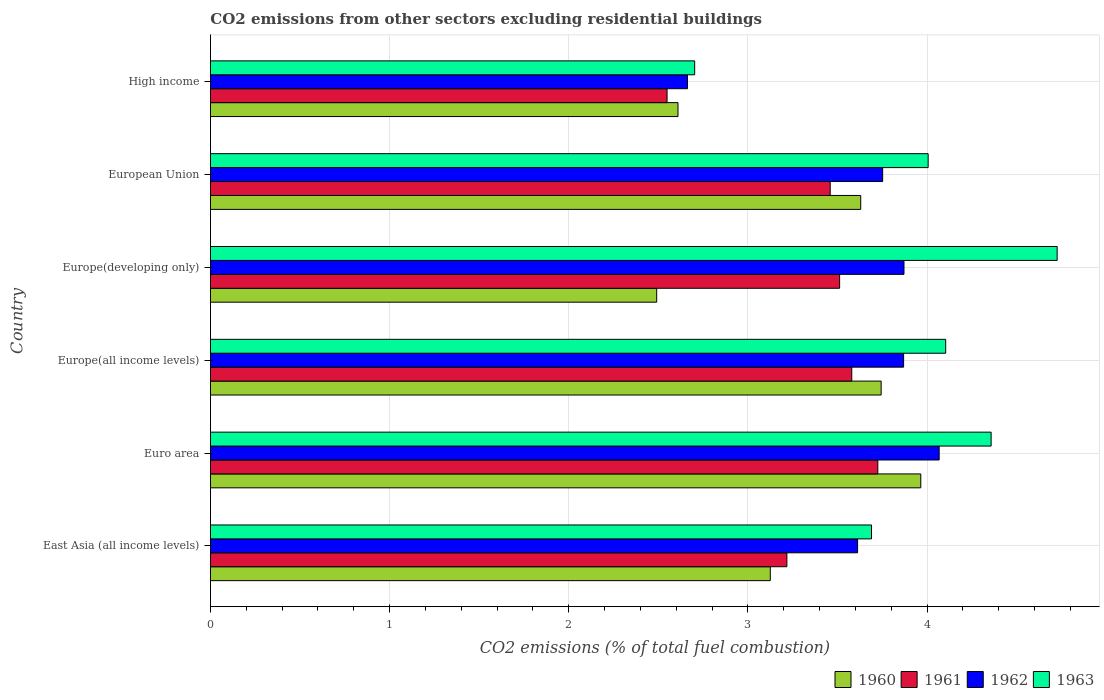Are the number of bars on each tick of the Y-axis equal?
Offer a very short reply. Yes. How many bars are there on the 3rd tick from the top?
Make the answer very short. 4. What is the label of the 4th group of bars from the top?
Offer a terse response. Europe(all income levels). In how many cases, is the number of bars for a given country not equal to the number of legend labels?
Provide a succinct answer. 0. What is the total CO2 emitted in 1963 in High income?
Make the answer very short. 2.7. Across all countries, what is the maximum total CO2 emitted in 1961?
Give a very brief answer. 3.73. Across all countries, what is the minimum total CO2 emitted in 1963?
Your response must be concise. 2.7. In which country was the total CO2 emitted in 1961 minimum?
Make the answer very short. High income. What is the total total CO2 emitted in 1962 in the graph?
Provide a short and direct response. 21.84. What is the difference between the total CO2 emitted in 1961 in East Asia (all income levels) and that in European Union?
Provide a short and direct response. -0.24. What is the difference between the total CO2 emitted in 1961 in High income and the total CO2 emitted in 1963 in East Asia (all income levels)?
Ensure brevity in your answer.  -1.14. What is the average total CO2 emitted in 1963 per country?
Your response must be concise. 3.93. What is the difference between the total CO2 emitted in 1960 and total CO2 emitted in 1963 in High income?
Your answer should be compact. -0.09. What is the ratio of the total CO2 emitted in 1962 in Europe(all income levels) to that in Europe(developing only)?
Ensure brevity in your answer.  1. Is the total CO2 emitted in 1962 in Europe(all income levels) less than that in High income?
Your answer should be compact. No. What is the difference between the highest and the second highest total CO2 emitted in 1961?
Offer a very short reply. 0.15. What is the difference between the highest and the lowest total CO2 emitted in 1963?
Keep it short and to the point. 2.02. Is it the case that in every country, the sum of the total CO2 emitted in 1960 and total CO2 emitted in 1962 is greater than the sum of total CO2 emitted in 1963 and total CO2 emitted in 1961?
Provide a succinct answer. No. What does the 1st bar from the bottom in High income represents?
Your answer should be very brief. 1960. Is it the case that in every country, the sum of the total CO2 emitted in 1961 and total CO2 emitted in 1960 is greater than the total CO2 emitted in 1963?
Give a very brief answer. Yes. How many bars are there?
Provide a succinct answer. 24. How many countries are there in the graph?
Keep it short and to the point. 6. What is the difference between two consecutive major ticks on the X-axis?
Provide a short and direct response. 1. How are the legend labels stacked?
Provide a succinct answer. Horizontal. What is the title of the graph?
Your answer should be very brief. CO2 emissions from other sectors excluding residential buildings. What is the label or title of the X-axis?
Your answer should be compact. CO2 emissions (% of total fuel combustion). What is the label or title of the Y-axis?
Offer a very short reply. Country. What is the CO2 emissions (% of total fuel combustion) of 1960 in East Asia (all income levels)?
Your answer should be compact. 3.13. What is the CO2 emissions (% of total fuel combustion) of 1961 in East Asia (all income levels)?
Offer a terse response. 3.22. What is the CO2 emissions (% of total fuel combustion) of 1962 in East Asia (all income levels)?
Provide a short and direct response. 3.61. What is the CO2 emissions (% of total fuel combustion) of 1963 in East Asia (all income levels)?
Your answer should be very brief. 3.69. What is the CO2 emissions (% of total fuel combustion) in 1960 in Euro area?
Your answer should be very brief. 3.97. What is the CO2 emissions (% of total fuel combustion) in 1961 in Euro area?
Your response must be concise. 3.73. What is the CO2 emissions (% of total fuel combustion) in 1962 in Euro area?
Provide a short and direct response. 4.07. What is the CO2 emissions (% of total fuel combustion) of 1963 in Euro area?
Make the answer very short. 4.36. What is the CO2 emissions (% of total fuel combustion) of 1960 in Europe(all income levels)?
Ensure brevity in your answer.  3.74. What is the CO2 emissions (% of total fuel combustion) in 1961 in Europe(all income levels)?
Your answer should be compact. 3.58. What is the CO2 emissions (% of total fuel combustion) in 1962 in Europe(all income levels)?
Give a very brief answer. 3.87. What is the CO2 emissions (% of total fuel combustion) in 1963 in Europe(all income levels)?
Your answer should be compact. 4.1. What is the CO2 emissions (% of total fuel combustion) in 1960 in Europe(developing only)?
Make the answer very short. 2.49. What is the CO2 emissions (% of total fuel combustion) in 1961 in Europe(developing only)?
Give a very brief answer. 3.51. What is the CO2 emissions (% of total fuel combustion) in 1962 in Europe(developing only)?
Give a very brief answer. 3.87. What is the CO2 emissions (% of total fuel combustion) in 1963 in Europe(developing only)?
Your response must be concise. 4.73. What is the CO2 emissions (% of total fuel combustion) of 1960 in European Union?
Offer a very short reply. 3.63. What is the CO2 emissions (% of total fuel combustion) of 1961 in European Union?
Offer a very short reply. 3.46. What is the CO2 emissions (% of total fuel combustion) in 1962 in European Union?
Offer a terse response. 3.75. What is the CO2 emissions (% of total fuel combustion) of 1963 in European Union?
Your response must be concise. 4.01. What is the CO2 emissions (% of total fuel combustion) of 1960 in High income?
Your response must be concise. 2.61. What is the CO2 emissions (% of total fuel combustion) of 1961 in High income?
Provide a succinct answer. 2.55. What is the CO2 emissions (% of total fuel combustion) of 1962 in High income?
Make the answer very short. 2.66. What is the CO2 emissions (% of total fuel combustion) of 1963 in High income?
Offer a very short reply. 2.7. Across all countries, what is the maximum CO2 emissions (% of total fuel combustion) in 1960?
Offer a terse response. 3.97. Across all countries, what is the maximum CO2 emissions (% of total fuel combustion) of 1961?
Your answer should be very brief. 3.73. Across all countries, what is the maximum CO2 emissions (% of total fuel combustion) in 1962?
Ensure brevity in your answer.  4.07. Across all countries, what is the maximum CO2 emissions (% of total fuel combustion) of 1963?
Offer a very short reply. 4.73. Across all countries, what is the minimum CO2 emissions (% of total fuel combustion) of 1960?
Ensure brevity in your answer.  2.49. Across all countries, what is the minimum CO2 emissions (% of total fuel combustion) in 1961?
Offer a very short reply. 2.55. Across all countries, what is the minimum CO2 emissions (% of total fuel combustion) of 1962?
Offer a very short reply. 2.66. Across all countries, what is the minimum CO2 emissions (% of total fuel combustion) of 1963?
Your answer should be very brief. 2.7. What is the total CO2 emissions (% of total fuel combustion) of 1960 in the graph?
Make the answer very short. 19.56. What is the total CO2 emissions (% of total fuel combustion) in 1961 in the graph?
Offer a very short reply. 20.04. What is the total CO2 emissions (% of total fuel combustion) in 1962 in the graph?
Ensure brevity in your answer.  21.84. What is the total CO2 emissions (% of total fuel combustion) of 1963 in the graph?
Your answer should be compact. 23.59. What is the difference between the CO2 emissions (% of total fuel combustion) of 1960 in East Asia (all income levels) and that in Euro area?
Provide a short and direct response. -0.84. What is the difference between the CO2 emissions (% of total fuel combustion) in 1961 in East Asia (all income levels) and that in Euro area?
Your answer should be very brief. -0.51. What is the difference between the CO2 emissions (% of total fuel combustion) of 1962 in East Asia (all income levels) and that in Euro area?
Make the answer very short. -0.46. What is the difference between the CO2 emissions (% of total fuel combustion) of 1963 in East Asia (all income levels) and that in Euro area?
Give a very brief answer. -0.67. What is the difference between the CO2 emissions (% of total fuel combustion) in 1960 in East Asia (all income levels) and that in Europe(all income levels)?
Offer a terse response. -0.62. What is the difference between the CO2 emissions (% of total fuel combustion) in 1961 in East Asia (all income levels) and that in Europe(all income levels)?
Offer a terse response. -0.36. What is the difference between the CO2 emissions (% of total fuel combustion) of 1962 in East Asia (all income levels) and that in Europe(all income levels)?
Ensure brevity in your answer.  -0.26. What is the difference between the CO2 emissions (% of total fuel combustion) in 1963 in East Asia (all income levels) and that in Europe(all income levels)?
Keep it short and to the point. -0.41. What is the difference between the CO2 emissions (% of total fuel combustion) of 1960 in East Asia (all income levels) and that in Europe(developing only)?
Your response must be concise. 0.63. What is the difference between the CO2 emissions (% of total fuel combustion) of 1961 in East Asia (all income levels) and that in Europe(developing only)?
Provide a short and direct response. -0.29. What is the difference between the CO2 emissions (% of total fuel combustion) in 1962 in East Asia (all income levels) and that in Europe(developing only)?
Your answer should be very brief. -0.26. What is the difference between the CO2 emissions (% of total fuel combustion) in 1963 in East Asia (all income levels) and that in Europe(developing only)?
Keep it short and to the point. -1.04. What is the difference between the CO2 emissions (% of total fuel combustion) of 1960 in East Asia (all income levels) and that in European Union?
Your response must be concise. -0.5. What is the difference between the CO2 emissions (% of total fuel combustion) in 1961 in East Asia (all income levels) and that in European Union?
Offer a terse response. -0.24. What is the difference between the CO2 emissions (% of total fuel combustion) of 1962 in East Asia (all income levels) and that in European Union?
Provide a short and direct response. -0.14. What is the difference between the CO2 emissions (% of total fuel combustion) in 1963 in East Asia (all income levels) and that in European Union?
Ensure brevity in your answer.  -0.32. What is the difference between the CO2 emissions (% of total fuel combustion) of 1960 in East Asia (all income levels) and that in High income?
Offer a terse response. 0.52. What is the difference between the CO2 emissions (% of total fuel combustion) in 1961 in East Asia (all income levels) and that in High income?
Your answer should be compact. 0.67. What is the difference between the CO2 emissions (% of total fuel combustion) in 1962 in East Asia (all income levels) and that in High income?
Provide a short and direct response. 0.95. What is the difference between the CO2 emissions (% of total fuel combustion) of 1960 in Euro area and that in Europe(all income levels)?
Your answer should be compact. 0.22. What is the difference between the CO2 emissions (% of total fuel combustion) of 1961 in Euro area and that in Europe(all income levels)?
Your answer should be very brief. 0.15. What is the difference between the CO2 emissions (% of total fuel combustion) in 1962 in Euro area and that in Europe(all income levels)?
Provide a short and direct response. 0.2. What is the difference between the CO2 emissions (% of total fuel combustion) in 1963 in Euro area and that in Europe(all income levels)?
Offer a terse response. 0.25. What is the difference between the CO2 emissions (% of total fuel combustion) in 1960 in Euro area and that in Europe(developing only)?
Offer a terse response. 1.47. What is the difference between the CO2 emissions (% of total fuel combustion) of 1961 in Euro area and that in Europe(developing only)?
Provide a short and direct response. 0.21. What is the difference between the CO2 emissions (% of total fuel combustion) in 1962 in Euro area and that in Europe(developing only)?
Make the answer very short. 0.2. What is the difference between the CO2 emissions (% of total fuel combustion) of 1963 in Euro area and that in Europe(developing only)?
Your answer should be very brief. -0.37. What is the difference between the CO2 emissions (% of total fuel combustion) of 1960 in Euro area and that in European Union?
Your answer should be very brief. 0.34. What is the difference between the CO2 emissions (% of total fuel combustion) in 1961 in Euro area and that in European Union?
Your response must be concise. 0.27. What is the difference between the CO2 emissions (% of total fuel combustion) in 1962 in Euro area and that in European Union?
Offer a terse response. 0.32. What is the difference between the CO2 emissions (% of total fuel combustion) in 1963 in Euro area and that in European Union?
Provide a succinct answer. 0.35. What is the difference between the CO2 emissions (% of total fuel combustion) of 1960 in Euro area and that in High income?
Your answer should be very brief. 1.36. What is the difference between the CO2 emissions (% of total fuel combustion) of 1961 in Euro area and that in High income?
Offer a terse response. 1.18. What is the difference between the CO2 emissions (% of total fuel combustion) in 1962 in Euro area and that in High income?
Provide a succinct answer. 1.41. What is the difference between the CO2 emissions (% of total fuel combustion) in 1963 in Euro area and that in High income?
Keep it short and to the point. 1.65. What is the difference between the CO2 emissions (% of total fuel combustion) of 1960 in Europe(all income levels) and that in Europe(developing only)?
Provide a succinct answer. 1.25. What is the difference between the CO2 emissions (% of total fuel combustion) in 1961 in Europe(all income levels) and that in Europe(developing only)?
Provide a succinct answer. 0.07. What is the difference between the CO2 emissions (% of total fuel combustion) in 1962 in Europe(all income levels) and that in Europe(developing only)?
Make the answer very short. -0. What is the difference between the CO2 emissions (% of total fuel combustion) in 1963 in Europe(all income levels) and that in Europe(developing only)?
Your answer should be very brief. -0.62. What is the difference between the CO2 emissions (% of total fuel combustion) of 1960 in Europe(all income levels) and that in European Union?
Offer a terse response. 0.11. What is the difference between the CO2 emissions (% of total fuel combustion) in 1961 in Europe(all income levels) and that in European Union?
Offer a very short reply. 0.12. What is the difference between the CO2 emissions (% of total fuel combustion) in 1962 in Europe(all income levels) and that in European Union?
Your answer should be very brief. 0.12. What is the difference between the CO2 emissions (% of total fuel combustion) of 1963 in Europe(all income levels) and that in European Union?
Offer a terse response. 0.1. What is the difference between the CO2 emissions (% of total fuel combustion) in 1960 in Europe(all income levels) and that in High income?
Keep it short and to the point. 1.13. What is the difference between the CO2 emissions (% of total fuel combustion) in 1961 in Europe(all income levels) and that in High income?
Your response must be concise. 1.03. What is the difference between the CO2 emissions (% of total fuel combustion) in 1962 in Europe(all income levels) and that in High income?
Provide a succinct answer. 1.21. What is the difference between the CO2 emissions (% of total fuel combustion) of 1963 in Europe(all income levels) and that in High income?
Make the answer very short. 1.4. What is the difference between the CO2 emissions (% of total fuel combustion) of 1960 in Europe(developing only) and that in European Union?
Provide a succinct answer. -1.14. What is the difference between the CO2 emissions (% of total fuel combustion) of 1961 in Europe(developing only) and that in European Union?
Provide a succinct answer. 0.05. What is the difference between the CO2 emissions (% of total fuel combustion) of 1962 in Europe(developing only) and that in European Union?
Provide a short and direct response. 0.12. What is the difference between the CO2 emissions (% of total fuel combustion) in 1963 in Europe(developing only) and that in European Union?
Your answer should be very brief. 0.72. What is the difference between the CO2 emissions (% of total fuel combustion) of 1960 in Europe(developing only) and that in High income?
Give a very brief answer. -0.12. What is the difference between the CO2 emissions (% of total fuel combustion) in 1961 in Europe(developing only) and that in High income?
Make the answer very short. 0.96. What is the difference between the CO2 emissions (% of total fuel combustion) in 1962 in Europe(developing only) and that in High income?
Your answer should be compact. 1.21. What is the difference between the CO2 emissions (% of total fuel combustion) in 1963 in Europe(developing only) and that in High income?
Your answer should be very brief. 2.02. What is the difference between the CO2 emissions (% of total fuel combustion) in 1960 in European Union and that in High income?
Ensure brevity in your answer.  1.02. What is the difference between the CO2 emissions (% of total fuel combustion) of 1961 in European Union and that in High income?
Provide a succinct answer. 0.91. What is the difference between the CO2 emissions (% of total fuel combustion) of 1962 in European Union and that in High income?
Your response must be concise. 1.09. What is the difference between the CO2 emissions (% of total fuel combustion) in 1963 in European Union and that in High income?
Your response must be concise. 1.3. What is the difference between the CO2 emissions (% of total fuel combustion) in 1960 in East Asia (all income levels) and the CO2 emissions (% of total fuel combustion) in 1961 in Euro area?
Keep it short and to the point. -0.6. What is the difference between the CO2 emissions (% of total fuel combustion) in 1960 in East Asia (all income levels) and the CO2 emissions (% of total fuel combustion) in 1962 in Euro area?
Your answer should be very brief. -0.94. What is the difference between the CO2 emissions (% of total fuel combustion) in 1960 in East Asia (all income levels) and the CO2 emissions (% of total fuel combustion) in 1963 in Euro area?
Provide a short and direct response. -1.23. What is the difference between the CO2 emissions (% of total fuel combustion) in 1961 in East Asia (all income levels) and the CO2 emissions (% of total fuel combustion) in 1962 in Euro area?
Ensure brevity in your answer.  -0.85. What is the difference between the CO2 emissions (% of total fuel combustion) in 1961 in East Asia (all income levels) and the CO2 emissions (% of total fuel combustion) in 1963 in Euro area?
Make the answer very short. -1.14. What is the difference between the CO2 emissions (% of total fuel combustion) in 1962 in East Asia (all income levels) and the CO2 emissions (% of total fuel combustion) in 1963 in Euro area?
Your response must be concise. -0.75. What is the difference between the CO2 emissions (% of total fuel combustion) of 1960 in East Asia (all income levels) and the CO2 emissions (% of total fuel combustion) of 1961 in Europe(all income levels)?
Keep it short and to the point. -0.45. What is the difference between the CO2 emissions (% of total fuel combustion) of 1960 in East Asia (all income levels) and the CO2 emissions (% of total fuel combustion) of 1962 in Europe(all income levels)?
Offer a very short reply. -0.74. What is the difference between the CO2 emissions (% of total fuel combustion) of 1960 in East Asia (all income levels) and the CO2 emissions (% of total fuel combustion) of 1963 in Europe(all income levels)?
Keep it short and to the point. -0.98. What is the difference between the CO2 emissions (% of total fuel combustion) of 1961 in East Asia (all income levels) and the CO2 emissions (% of total fuel combustion) of 1962 in Europe(all income levels)?
Ensure brevity in your answer.  -0.65. What is the difference between the CO2 emissions (% of total fuel combustion) in 1961 in East Asia (all income levels) and the CO2 emissions (% of total fuel combustion) in 1963 in Europe(all income levels)?
Provide a succinct answer. -0.89. What is the difference between the CO2 emissions (% of total fuel combustion) in 1962 in East Asia (all income levels) and the CO2 emissions (% of total fuel combustion) in 1963 in Europe(all income levels)?
Keep it short and to the point. -0.49. What is the difference between the CO2 emissions (% of total fuel combustion) of 1960 in East Asia (all income levels) and the CO2 emissions (% of total fuel combustion) of 1961 in Europe(developing only)?
Offer a very short reply. -0.39. What is the difference between the CO2 emissions (% of total fuel combustion) in 1960 in East Asia (all income levels) and the CO2 emissions (% of total fuel combustion) in 1962 in Europe(developing only)?
Make the answer very short. -0.75. What is the difference between the CO2 emissions (% of total fuel combustion) in 1960 in East Asia (all income levels) and the CO2 emissions (% of total fuel combustion) in 1963 in Europe(developing only)?
Keep it short and to the point. -1.6. What is the difference between the CO2 emissions (% of total fuel combustion) in 1961 in East Asia (all income levels) and the CO2 emissions (% of total fuel combustion) in 1962 in Europe(developing only)?
Offer a terse response. -0.65. What is the difference between the CO2 emissions (% of total fuel combustion) of 1961 in East Asia (all income levels) and the CO2 emissions (% of total fuel combustion) of 1963 in Europe(developing only)?
Your answer should be compact. -1.51. What is the difference between the CO2 emissions (% of total fuel combustion) in 1962 in East Asia (all income levels) and the CO2 emissions (% of total fuel combustion) in 1963 in Europe(developing only)?
Make the answer very short. -1.11. What is the difference between the CO2 emissions (% of total fuel combustion) of 1960 in East Asia (all income levels) and the CO2 emissions (% of total fuel combustion) of 1961 in European Union?
Make the answer very short. -0.33. What is the difference between the CO2 emissions (% of total fuel combustion) of 1960 in East Asia (all income levels) and the CO2 emissions (% of total fuel combustion) of 1962 in European Union?
Offer a terse response. -0.63. What is the difference between the CO2 emissions (% of total fuel combustion) in 1960 in East Asia (all income levels) and the CO2 emissions (% of total fuel combustion) in 1963 in European Union?
Your answer should be very brief. -0.88. What is the difference between the CO2 emissions (% of total fuel combustion) of 1961 in East Asia (all income levels) and the CO2 emissions (% of total fuel combustion) of 1962 in European Union?
Keep it short and to the point. -0.53. What is the difference between the CO2 emissions (% of total fuel combustion) of 1961 in East Asia (all income levels) and the CO2 emissions (% of total fuel combustion) of 1963 in European Union?
Provide a short and direct response. -0.79. What is the difference between the CO2 emissions (% of total fuel combustion) in 1962 in East Asia (all income levels) and the CO2 emissions (% of total fuel combustion) in 1963 in European Union?
Provide a succinct answer. -0.39. What is the difference between the CO2 emissions (% of total fuel combustion) of 1960 in East Asia (all income levels) and the CO2 emissions (% of total fuel combustion) of 1961 in High income?
Give a very brief answer. 0.58. What is the difference between the CO2 emissions (% of total fuel combustion) of 1960 in East Asia (all income levels) and the CO2 emissions (% of total fuel combustion) of 1962 in High income?
Provide a succinct answer. 0.46. What is the difference between the CO2 emissions (% of total fuel combustion) of 1960 in East Asia (all income levels) and the CO2 emissions (% of total fuel combustion) of 1963 in High income?
Give a very brief answer. 0.42. What is the difference between the CO2 emissions (% of total fuel combustion) in 1961 in East Asia (all income levels) and the CO2 emissions (% of total fuel combustion) in 1962 in High income?
Give a very brief answer. 0.55. What is the difference between the CO2 emissions (% of total fuel combustion) of 1961 in East Asia (all income levels) and the CO2 emissions (% of total fuel combustion) of 1963 in High income?
Ensure brevity in your answer.  0.51. What is the difference between the CO2 emissions (% of total fuel combustion) of 1962 in East Asia (all income levels) and the CO2 emissions (% of total fuel combustion) of 1963 in High income?
Provide a succinct answer. 0.91. What is the difference between the CO2 emissions (% of total fuel combustion) in 1960 in Euro area and the CO2 emissions (% of total fuel combustion) in 1961 in Europe(all income levels)?
Your answer should be compact. 0.39. What is the difference between the CO2 emissions (% of total fuel combustion) in 1960 in Euro area and the CO2 emissions (% of total fuel combustion) in 1962 in Europe(all income levels)?
Your answer should be very brief. 0.1. What is the difference between the CO2 emissions (% of total fuel combustion) in 1960 in Euro area and the CO2 emissions (% of total fuel combustion) in 1963 in Europe(all income levels)?
Offer a very short reply. -0.14. What is the difference between the CO2 emissions (% of total fuel combustion) in 1961 in Euro area and the CO2 emissions (% of total fuel combustion) in 1962 in Europe(all income levels)?
Your answer should be very brief. -0.14. What is the difference between the CO2 emissions (% of total fuel combustion) in 1961 in Euro area and the CO2 emissions (% of total fuel combustion) in 1963 in Europe(all income levels)?
Your response must be concise. -0.38. What is the difference between the CO2 emissions (% of total fuel combustion) in 1962 in Euro area and the CO2 emissions (% of total fuel combustion) in 1963 in Europe(all income levels)?
Your answer should be very brief. -0.04. What is the difference between the CO2 emissions (% of total fuel combustion) of 1960 in Euro area and the CO2 emissions (% of total fuel combustion) of 1961 in Europe(developing only)?
Give a very brief answer. 0.45. What is the difference between the CO2 emissions (% of total fuel combustion) of 1960 in Euro area and the CO2 emissions (% of total fuel combustion) of 1962 in Europe(developing only)?
Provide a short and direct response. 0.09. What is the difference between the CO2 emissions (% of total fuel combustion) in 1960 in Euro area and the CO2 emissions (% of total fuel combustion) in 1963 in Europe(developing only)?
Offer a very short reply. -0.76. What is the difference between the CO2 emissions (% of total fuel combustion) of 1961 in Euro area and the CO2 emissions (% of total fuel combustion) of 1962 in Europe(developing only)?
Provide a short and direct response. -0.15. What is the difference between the CO2 emissions (% of total fuel combustion) of 1961 in Euro area and the CO2 emissions (% of total fuel combustion) of 1963 in Europe(developing only)?
Your answer should be compact. -1. What is the difference between the CO2 emissions (% of total fuel combustion) of 1962 in Euro area and the CO2 emissions (% of total fuel combustion) of 1963 in Europe(developing only)?
Your answer should be very brief. -0.66. What is the difference between the CO2 emissions (% of total fuel combustion) in 1960 in Euro area and the CO2 emissions (% of total fuel combustion) in 1961 in European Union?
Keep it short and to the point. 0.51. What is the difference between the CO2 emissions (% of total fuel combustion) in 1960 in Euro area and the CO2 emissions (% of total fuel combustion) in 1962 in European Union?
Your response must be concise. 0.21. What is the difference between the CO2 emissions (% of total fuel combustion) of 1960 in Euro area and the CO2 emissions (% of total fuel combustion) of 1963 in European Union?
Make the answer very short. -0.04. What is the difference between the CO2 emissions (% of total fuel combustion) of 1961 in Euro area and the CO2 emissions (% of total fuel combustion) of 1962 in European Union?
Offer a very short reply. -0.03. What is the difference between the CO2 emissions (% of total fuel combustion) in 1961 in Euro area and the CO2 emissions (% of total fuel combustion) in 1963 in European Union?
Keep it short and to the point. -0.28. What is the difference between the CO2 emissions (% of total fuel combustion) of 1962 in Euro area and the CO2 emissions (% of total fuel combustion) of 1963 in European Union?
Offer a terse response. 0.06. What is the difference between the CO2 emissions (% of total fuel combustion) of 1960 in Euro area and the CO2 emissions (% of total fuel combustion) of 1961 in High income?
Your response must be concise. 1.42. What is the difference between the CO2 emissions (% of total fuel combustion) in 1960 in Euro area and the CO2 emissions (% of total fuel combustion) in 1962 in High income?
Provide a short and direct response. 1.3. What is the difference between the CO2 emissions (% of total fuel combustion) in 1960 in Euro area and the CO2 emissions (% of total fuel combustion) in 1963 in High income?
Make the answer very short. 1.26. What is the difference between the CO2 emissions (% of total fuel combustion) in 1961 in Euro area and the CO2 emissions (% of total fuel combustion) in 1963 in High income?
Your answer should be compact. 1.02. What is the difference between the CO2 emissions (% of total fuel combustion) of 1962 in Euro area and the CO2 emissions (% of total fuel combustion) of 1963 in High income?
Offer a very short reply. 1.36. What is the difference between the CO2 emissions (% of total fuel combustion) in 1960 in Europe(all income levels) and the CO2 emissions (% of total fuel combustion) in 1961 in Europe(developing only)?
Provide a succinct answer. 0.23. What is the difference between the CO2 emissions (% of total fuel combustion) of 1960 in Europe(all income levels) and the CO2 emissions (% of total fuel combustion) of 1962 in Europe(developing only)?
Keep it short and to the point. -0.13. What is the difference between the CO2 emissions (% of total fuel combustion) in 1960 in Europe(all income levels) and the CO2 emissions (% of total fuel combustion) in 1963 in Europe(developing only)?
Provide a short and direct response. -0.98. What is the difference between the CO2 emissions (% of total fuel combustion) of 1961 in Europe(all income levels) and the CO2 emissions (% of total fuel combustion) of 1962 in Europe(developing only)?
Offer a very short reply. -0.29. What is the difference between the CO2 emissions (% of total fuel combustion) of 1961 in Europe(all income levels) and the CO2 emissions (% of total fuel combustion) of 1963 in Europe(developing only)?
Make the answer very short. -1.15. What is the difference between the CO2 emissions (% of total fuel combustion) in 1962 in Europe(all income levels) and the CO2 emissions (% of total fuel combustion) in 1963 in Europe(developing only)?
Provide a short and direct response. -0.86. What is the difference between the CO2 emissions (% of total fuel combustion) of 1960 in Europe(all income levels) and the CO2 emissions (% of total fuel combustion) of 1961 in European Union?
Your answer should be compact. 0.28. What is the difference between the CO2 emissions (% of total fuel combustion) in 1960 in Europe(all income levels) and the CO2 emissions (% of total fuel combustion) in 1962 in European Union?
Give a very brief answer. -0.01. What is the difference between the CO2 emissions (% of total fuel combustion) in 1960 in Europe(all income levels) and the CO2 emissions (% of total fuel combustion) in 1963 in European Union?
Offer a very short reply. -0.26. What is the difference between the CO2 emissions (% of total fuel combustion) in 1961 in Europe(all income levels) and the CO2 emissions (% of total fuel combustion) in 1962 in European Union?
Make the answer very short. -0.17. What is the difference between the CO2 emissions (% of total fuel combustion) of 1961 in Europe(all income levels) and the CO2 emissions (% of total fuel combustion) of 1963 in European Union?
Your answer should be compact. -0.43. What is the difference between the CO2 emissions (% of total fuel combustion) of 1962 in Europe(all income levels) and the CO2 emissions (% of total fuel combustion) of 1963 in European Union?
Your response must be concise. -0.14. What is the difference between the CO2 emissions (% of total fuel combustion) of 1960 in Europe(all income levels) and the CO2 emissions (% of total fuel combustion) of 1961 in High income?
Provide a short and direct response. 1.2. What is the difference between the CO2 emissions (% of total fuel combustion) of 1960 in Europe(all income levels) and the CO2 emissions (% of total fuel combustion) of 1962 in High income?
Your answer should be compact. 1.08. What is the difference between the CO2 emissions (% of total fuel combustion) of 1960 in Europe(all income levels) and the CO2 emissions (% of total fuel combustion) of 1963 in High income?
Ensure brevity in your answer.  1.04. What is the difference between the CO2 emissions (% of total fuel combustion) of 1961 in Europe(all income levels) and the CO2 emissions (% of total fuel combustion) of 1962 in High income?
Offer a very short reply. 0.92. What is the difference between the CO2 emissions (% of total fuel combustion) of 1961 in Europe(all income levels) and the CO2 emissions (% of total fuel combustion) of 1963 in High income?
Keep it short and to the point. 0.88. What is the difference between the CO2 emissions (% of total fuel combustion) of 1962 in Europe(all income levels) and the CO2 emissions (% of total fuel combustion) of 1963 in High income?
Keep it short and to the point. 1.17. What is the difference between the CO2 emissions (% of total fuel combustion) of 1960 in Europe(developing only) and the CO2 emissions (% of total fuel combustion) of 1961 in European Union?
Make the answer very short. -0.97. What is the difference between the CO2 emissions (% of total fuel combustion) in 1960 in Europe(developing only) and the CO2 emissions (% of total fuel combustion) in 1962 in European Union?
Your answer should be very brief. -1.26. What is the difference between the CO2 emissions (% of total fuel combustion) in 1960 in Europe(developing only) and the CO2 emissions (% of total fuel combustion) in 1963 in European Union?
Make the answer very short. -1.52. What is the difference between the CO2 emissions (% of total fuel combustion) in 1961 in Europe(developing only) and the CO2 emissions (% of total fuel combustion) in 1962 in European Union?
Keep it short and to the point. -0.24. What is the difference between the CO2 emissions (% of total fuel combustion) in 1961 in Europe(developing only) and the CO2 emissions (% of total fuel combustion) in 1963 in European Union?
Provide a succinct answer. -0.49. What is the difference between the CO2 emissions (% of total fuel combustion) of 1962 in Europe(developing only) and the CO2 emissions (% of total fuel combustion) of 1963 in European Union?
Your answer should be compact. -0.14. What is the difference between the CO2 emissions (% of total fuel combustion) in 1960 in Europe(developing only) and the CO2 emissions (% of total fuel combustion) in 1961 in High income?
Offer a very short reply. -0.06. What is the difference between the CO2 emissions (% of total fuel combustion) in 1960 in Europe(developing only) and the CO2 emissions (% of total fuel combustion) in 1962 in High income?
Offer a terse response. -0.17. What is the difference between the CO2 emissions (% of total fuel combustion) in 1960 in Europe(developing only) and the CO2 emissions (% of total fuel combustion) in 1963 in High income?
Offer a terse response. -0.21. What is the difference between the CO2 emissions (% of total fuel combustion) of 1961 in Europe(developing only) and the CO2 emissions (% of total fuel combustion) of 1962 in High income?
Offer a very short reply. 0.85. What is the difference between the CO2 emissions (% of total fuel combustion) in 1961 in Europe(developing only) and the CO2 emissions (% of total fuel combustion) in 1963 in High income?
Your answer should be very brief. 0.81. What is the difference between the CO2 emissions (% of total fuel combustion) of 1962 in Europe(developing only) and the CO2 emissions (% of total fuel combustion) of 1963 in High income?
Give a very brief answer. 1.17. What is the difference between the CO2 emissions (% of total fuel combustion) of 1960 in European Union and the CO2 emissions (% of total fuel combustion) of 1961 in High income?
Offer a terse response. 1.08. What is the difference between the CO2 emissions (% of total fuel combustion) in 1960 in European Union and the CO2 emissions (% of total fuel combustion) in 1962 in High income?
Offer a terse response. 0.97. What is the difference between the CO2 emissions (% of total fuel combustion) in 1960 in European Union and the CO2 emissions (% of total fuel combustion) in 1963 in High income?
Give a very brief answer. 0.93. What is the difference between the CO2 emissions (% of total fuel combustion) in 1961 in European Union and the CO2 emissions (% of total fuel combustion) in 1962 in High income?
Provide a short and direct response. 0.8. What is the difference between the CO2 emissions (% of total fuel combustion) in 1961 in European Union and the CO2 emissions (% of total fuel combustion) in 1963 in High income?
Your answer should be very brief. 0.76. What is the difference between the CO2 emissions (% of total fuel combustion) of 1962 in European Union and the CO2 emissions (% of total fuel combustion) of 1963 in High income?
Your response must be concise. 1.05. What is the average CO2 emissions (% of total fuel combustion) of 1960 per country?
Keep it short and to the point. 3.26. What is the average CO2 emissions (% of total fuel combustion) of 1961 per country?
Keep it short and to the point. 3.34. What is the average CO2 emissions (% of total fuel combustion) of 1962 per country?
Give a very brief answer. 3.64. What is the average CO2 emissions (% of total fuel combustion) of 1963 per country?
Make the answer very short. 3.93. What is the difference between the CO2 emissions (% of total fuel combustion) of 1960 and CO2 emissions (% of total fuel combustion) of 1961 in East Asia (all income levels)?
Provide a succinct answer. -0.09. What is the difference between the CO2 emissions (% of total fuel combustion) in 1960 and CO2 emissions (% of total fuel combustion) in 1962 in East Asia (all income levels)?
Provide a succinct answer. -0.49. What is the difference between the CO2 emissions (% of total fuel combustion) in 1960 and CO2 emissions (% of total fuel combustion) in 1963 in East Asia (all income levels)?
Your answer should be compact. -0.56. What is the difference between the CO2 emissions (% of total fuel combustion) in 1961 and CO2 emissions (% of total fuel combustion) in 1962 in East Asia (all income levels)?
Make the answer very short. -0.39. What is the difference between the CO2 emissions (% of total fuel combustion) in 1961 and CO2 emissions (% of total fuel combustion) in 1963 in East Asia (all income levels)?
Your response must be concise. -0.47. What is the difference between the CO2 emissions (% of total fuel combustion) in 1962 and CO2 emissions (% of total fuel combustion) in 1963 in East Asia (all income levels)?
Give a very brief answer. -0.08. What is the difference between the CO2 emissions (% of total fuel combustion) in 1960 and CO2 emissions (% of total fuel combustion) in 1961 in Euro area?
Offer a terse response. 0.24. What is the difference between the CO2 emissions (% of total fuel combustion) in 1960 and CO2 emissions (% of total fuel combustion) in 1962 in Euro area?
Provide a short and direct response. -0.1. What is the difference between the CO2 emissions (% of total fuel combustion) in 1960 and CO2 emissions (% of total fuel combustion) in 1963 in Euro area?
Offer a terse response. -0.39. What is the difference between the CO2 emissions (% of total fuel combustion) in 1961 and CO2 emissions (% of total fuel combustion) in 1962 in Euro area?
Provide a short and direct response. -0.34. What is the difference between the CO2 emissions (% of total fuel combustion) of 1961 and CO2 emissions (% of total fuel combustion) of 1963 in Euro area?
Offer a terse response. -0.63. What is the difference between the CO2 emissions (% of total fuel combustion) in 1962 and CO2 emissions (% of total fuel combustion) in 1963 in Euro area?
Offer a very short reply. -0.29. What is the difference between the CO2 emissions (% of total fuel combustion) of 1960 and CO2 emissions (% of total fuel combustion) of 1961 in Europe(all income levels)?
Make the answer very short. 0.16. What is the difference between the CO2 emissions (% of total fuel combustion) of 1960 and CO2 emissions (% of total fuel combustion) of 1962 in Europe(all income levels)?
Provide a succinct answer. -0.13. What is the difference between the CO2 emissions (% of total fuel combustion) in 1960 and CO2 emissions (% of total fuel combustion) in 1963 in Europe(all income levels)?
Provide a short and direct response. -0.36. What is the difference between the CO2 emissions (% of total fuel combustion) of 1961 and CO2 emissions (% of total fuel combustion) of 1962 in Europe(all income levels)?
Offer a very short reply. -0.29. What is the difference between the CO2 emissions (% of total fuel combustion) of 1961 and CO2 emissions (% of total fuel combustion) of 1963 in Europe(all income levels)?
Your response must be concise. -0.52. What is the difference between the CO2 emissions (% of total fuel combustion) in 1962 and CO2 emissions (% of total fuel combustion) in 1963 in Europe(all income levels)?
Your answer should be very brief. -0.23. What is the difference between the CO2 emissions (% of total fuel combustion) in 1960 and CO2 emissions (% of total fuel combustion) in 1961 in Europe(developing only)?
Your answer should be very brief. -1.02. What is the difference between the CO2 emissions (% of total fuel combustion) in 1960 and CO2 emissions (% of total fuel combustion) in 1962 in Europe(developing only)?
Your answer should be very brief. -1.38. What is the difference between the CO2 emissions (% of total fuel combustion) of 1960 and CO2 emissions (% of total fuel combustion) of 1963 in Europe(developing only)?
Your answer should be compact. -2.24. What is the difference between the CO2 emissions (% of total fuel combustion) of 1961 and CO2 emissions (% of total fuel combustion) of 1962 in Europe(developing only)?
Give a very brief answer. -0.36. What is the difference between the CO2 emissions (% of total fuel combustion) of 1961 and CO2 emissions (% of total fuel combustion) of 1963 in Europe(developing only)?
Your answer should be compact. -1.21. What is the difference between the CO2 emissions (% of total fuel combustion) in 1962 and CO2 emissions (% of total fuel combustion) in 1963 in Europe(developing only)?
Your response must be concise. -0.85. What is the difference between the CO2 emissions (% of total fuel combustion) in 1960 and CO2 emissions (% of total fuel combustion) in 1961 in European Union?
Offer a terse response. 0.17. What is the difference between the CO2 emissions (% of total fuel combustion) of 1960 and CO2 emissions (% of total fuel combustion) of 1962 in European Union?
Your answer should be very brief. -0.12. What is the difference between the CO2 emissions (% of total fuel combustion) of 1960 and CO2 emissions (% of total fuel combustion) of 1963 in European Union?
Give a very brief answer. -0.38. What is the difference between the CO2 emissions (% of total fuel combustion) of 1961 and CO2 emissions (% of total fuel combustion) of 1962 in European Union?
Give a very brief answer. -0.29. What is the difference between the CO2 emissions (% of total fuel combustion) of 1961 and CO2 emissions (% of total fuel combustion) of 1963 in European Union?
Provide a succinct answer. -0.55. What is the difference between the CO2 emissions (% of total fuel combustion) in 1962 and CO2 emissions (% of total fuel combustion) in 1963 in European Union?
Provide a succinct answer. -0.25. What is the difference between the CO2 emissions (% of total fuel combustion) in 1960 and CO2 emissions (% of total fuel combustion) in 1961 in High income?
Your response must be concise. 0.06. What is the difference between the CO2 emissions (% of total fuel combustion) of 1960 and CO2 emissions (% of total fuel combustion) of 1962 in High income?
Your answer should be compact. -0.05. What is the difference between the CO2 emissions (% of total fuel combustion) of 1960 and CO2 emissions (% of total fuel combustion) of 1963 in High income?
Ensure brevity in your answer.  -0.09. What is the difference between the CO2 emissions (% of total fuel combustion) of 1961 and CO2 emissions (% of total fuel combustion) of 1962 in High income?
Give a very brief answer. -0.11. What is the difference between the CO2 emissions (% of total fuel combustion) in 1961 and CO2 emissions (% of total fuel combustion) in 1963 in High income?
Provide a short and direct response. -0.15. What is the difference between the CO2 emissions (% of total fuel combustion) in 1962 and CO2 emissions (% of total fuel combustion) in 1963 in High income?
Your answer should be compact. -0.04. What is the ratio of the CO2 emissions (% of total fuel combustion) of 1960 in East Asia (all income levels) to that in Euro area?
Your answer should be very brief. 0.79. What is the ratio of the CO2 emissions (% of total fuel combustion) in 1961 in East Asia (all income levels) to that in Euro area?
Offer a very short reply. 0.86. What is the ratio of the CO2 emissions (% of total fuel combustion) of 1962 in East Asia (all income levels) to that in Euro area?
Give a very brief answer. 0.89. What is the ratio of the CO2 emissions (% of total fuel combustion) in 1963 in East Asia (all income levels) to that in Euro area?
Provide a short and direct response. 0.85. What is the ratio of the CO2 emissions (% of total fuel combustion) in 1960 in East Asia (all income levels) to that in Europe(all income levels)?
Your answer should be very brief. 0.83. What is the ratio of the CO2 emissions (% of total fuel combustion) in 1961 in East Asia (all income levels) to that in Europe(all income levels)?
Keep it short and to the point. 0.9. What is the ratio of the CO2 emissions (% of total fuel combustion) in 1962 in East Asia (all income levels) to that in Europe(all income levels)?
Provide a succinct answer. 0.93. What is the ratio of the CO2 emissions (% of total fuel combustion) of 1963 in East Asia (all income levels) to that in Europe(all income levels)?
Offer a very short reply. 0.9. What is the ratio of the CO2 emissions (% of total fuel combustion) of 1960 in East Asia (all income levels) to that in Europe(developing only)?
Offer a very short reply. 1.25. What is the ratio of the CO2 emissions (% of total fuel combustion) of 1961 in East Asia (all income levels) to that in Europe(developing only)?
Ensure brevity in your answer.  0.92. What is the ratio of the CO2 emissions (% of total fuel combustion) in 1962 in East Asia (all income levels) to that in Europe(developing only)?
Your answer should be very brief. 0.93. What is the ratio of the CO2 emissions (% of total fuel combustion) of 1963 in East Asia (all income levels) to that in Europe(developing only)?
Offer a very short reply. 0.78. What is the ratio of the CO2 emissions (% of total fuel combustion) of 1960 in East Asia (all income levels) to that in European Union?
Provide a succinct answer. 0.86. What is the ratio of the CO2 emissions (% of total fuel combustion) in 1961 in East Asia (all income levels) to that in European Union?
Offer a very short reply. 0.93. What is the ratio of the CO2 emissions (% of total fuel combustion) of 1962 in East Asia (all income levels) to that in European Union?
Provide a succinct answer. 0.96. What is the ratio of the CO2 emissions (% of total fuel combustion) of 1963 in East Asia (all income levels) to that in European Union?
Ensure brevity in your answer.  0.92. What is the ratio of the CO2 emissions (% of total fuel combustion) of 1960 in East Asia (all income levels) to that in High income?
Ensure brevity in your answer.  1.2. What is the ratio of the CO2 emissions (% of total fuel combustion) of 1961 in East Asia (all income levels) to that in High income?
Provide a short and direct response. 1.26. What is the ratio of the CO2 emissions (% of total fuel combustion) of 1962 in East Asia (all income levels) to that in High income?
Your response must be concise. 1.36. What is the ratio of the CO2 emissions (% of total fuel combustion) of 1963 in East Asia (all income levels) to that in High income?
Provide a short and direct response. 1.37. What is the ratio of the CO2 emissions (% of total fuel combustion) of 1960 in Euro area to that in Europe(all income levels)?
Your response must be concise. 1.06. What is the ratio of the CO2 emissions (% of total fuel combustion) of 1961 in Euro area to that in Europe(all income levels)?
Provide a succinct answer. 1.04. What is the ratio of the CO2 emissions (% of total fuel combustion) in 1962 in Euro area to that in Europe(all income levels)?
Offer a terse response. 1.05. What is the ratio of the CO2 emissions (% of total fuel combustion) of 1963 in Euro area to that in Europe(all income levels)?
Keep it short and to the point. 1.06. What is the ratio of the CO2 emissions (% of total fuel combustion) of 1960 in Euro area to that in Europe(developing only)?
Your answer should be compact. 1.59. What is the ratio of the CO2 emissions (% of total fuel combustion) of 1961 in Euro area to that in Europe(developing only)?
Your answer should be very brief. 1.06. What is the ratio of the CO2 emissions (% of total fuel combustion) of 1962 in Euro area to that in Europe(developing only)?
Give a very brief answer. 1.05. What is the ratio of the CO2 emissions (% of total fuel combustion) of 1963 in Euro area to that in Europe(developing only)?
Your answer should be very brief. 0.92. What is the ratio of the CO2 emissions (% of total fuel combustion) of 1960 in Euro area to that in European Union?
Offer a very short reply. 1.09. What is the ratio of the CO2 emissions (% of total fuel combustion) of 1961 in Euro area to that in European Union?
Give a very brief answer. 1.08. What is the ratio of the CO2 emissions (% of total fuel combustion) in 1962 in Euro area to that in European Union?
Give a very brief answer. 1.08. What is the ratio of the CO2 emissions (% of total fuel combustion) in 1963 in Euro area to that in European Union?
Keep it short and to the point. 1.09. What is the ratio of the CO2 emissions (% of total fuel combustion) in 1960 in Euro area to that in High income?
Keep it short and to the point. 1.52. What is the ratio of the CO2 emissions (% of total fuel combustion) in 1961 in Euro area to that in High income?
Keep it short and to the point. 1.46. What is the ratio of the CO2 emissions (% of total fuel combustion) of 1962 in Euro area to that in High income?
Your answer should be very brief. 1.53. What is the ratio of the CO2 emissions (% of total fuel combustion) in 1963 in Euro area to that in High income?
Give a very brief answer. 1.61. What is the ratio of the CO2 emissions (% of total fuel combustion) of 1960 in Europe(all income levels) to that in Europe(developing only)?
Your response must be concise. 1.5. What is the ratio of the CO2 emissions (% of total fuel combustion) of 1961 in Europe(all income levels) to that in Europe(developing only)?
Give a very brief answer. 1.02. What is the ratio of the CO2 emissions (% of total fuel combustion) in 1962 in Europe(all income levels) to that in Europe(developing only)?
Ensure brevity in your answer.  1. What is the ratio of the CO2 emissions (% of total fuel combustion) of 1963 in Europe(all income levels) to that in Europe(developing only)?
Provide a short and direct response. 0.87. What is the ratio of the CO2 emissions (% of total fuel combustion) in 1960 in Europe(all income levels) to that in European Union?
Offer a very short reply. 1.03. What is the ratio of the CO2 emissions (% of total fuel combustion) of 1961 in Europe(all income levels) to that in European Union?
Your answer should be compact. 1.03. What is the ratio of the CO2 emissions (% of total fuel combustion) in 1962 in Europe(all income levels) to that in European Union?
Provide a short and direct response. 1.03. What is the ratio of the CO2 emissions (% of total fuel combustion) of 1963 in Europe(all income levels) to that in European Union?
Ensure brevity in your answer.  1.02. What is the ratio of the CO2 emissions (% of total fuel combustion) in 1960 in Europe(all income levels) to that in High income?
Provide a succinct answer. 1.43. What is the ratio of the CO2 emissions (% of total fuel combustion) of 1961 in Europe(all income levels) to that in High income?
Your answer should be compact. 1.4. What is the ratio of the CO2 emissions (% of total fuel combustion) of 1962 in Europe(all income levels) to that in High income?
Your answer should be compact. 1.45. What is the ratio of the CO2 emissions (% of total fuel combustion) in 1963 in Europe(all income levels) to that in High income?
Give a very brief answer. 1.52. What is the ratio of the CO2 emissions (% of total fuel combustion) in 1960 in Europe(developing only) to that in European Union?
Your response must be concise. 0.69. What is the ratio of the CO2 emissions (% of total fuel combustion) in 1961 in Europe(developing only) to that in European Union?
Ensure brevity in your answer.  1.02. What is the ratio of the CO2 emissions (% of total fuel combustion) in 1962 in Europe(developing only) to that in European Union?
Make the answer very short. 1.03. What is the ratio of the CO2 emissions (% of total fuel combustion) of 1963 in Europe(developing only) to that in European Union?
Make the answer very short. 1.18. What is the ratio of the CO2 emissions (% of total fuel combustion) of 1960 in Europe(developing only) to that in High income?
Your answer should be compact. 0.95. What is the ratio of the CO2 emissions (% of total fuel combustion) in 1961 in Europe(developing only) to that in High income?
Provide a succinct answer. 1.38. What is the ratio of the CO2 emissions (% of total fuel combustion) of 1962 in Europe(developing only) to that in High income?
Keep it short and to the point. 1.45. What is the ratio of the CO2 emissions (% of total fuel combustion) in 1963 in Europe(developing only) to that in High income?
Offer a terse response. 1.75. What is the ratio of the CO2 emissions (% of total fuel combustion) in 1960 in European Union to that in High income?
Offer a very short reply. 1.39. What is the ratio of the CO2 emissions (% of total fuel combustion) of 1961 in European Union to that in High income?
Your answer should be very brief. 1.36. What is the ratio of the CO2 emissions (% of total fuel combustion) in 1962 in European Union to that in High income?
Your response must be concise. 1.41. What is the ratio of the CO2 emissions (% of total fuel combustion) in 1963 in European Union to that in High income?
Your answer should be very brief. 1.48. What is the difference between the highest and the second highest CO2 emissions (% of total fuel combustion) of 1960?
Your answer should be compact. 0.22. What is the difference between the highest and the second highest CO2 emissions (% of total fuel combustion) of 1961?
Your answer should be compact. 0.15. What is the difference between the highest and the second highest CO2 emissions (% of total fuel combustion) in 1962?
Your answer should be very brief. 0.2. What is the difference between the highest and the second highest CO2 emissions (% of total fuel combustion) in 1963?
Offer a very short reply. 0.37. What is the difference between the highest and the lowest CO2 emissions (% of total fuel combustion) of 1960?
Provide a short and direct response. 1.47. What is the difference between the highest and the lowest CO2 emissions (% of total fuel combustion) of 1961?
Your answer should be very brief. 1.18. What is the difference between the highest and the lowest CO2 emissions (% of total fuel combustion) of 1962?
Provide a short and direct response. 1.41. What is the difference between the highest and the lowest CO2 emissions (% of total fuel combustion) in 1963?
Give a very brief answer. 2.02. 